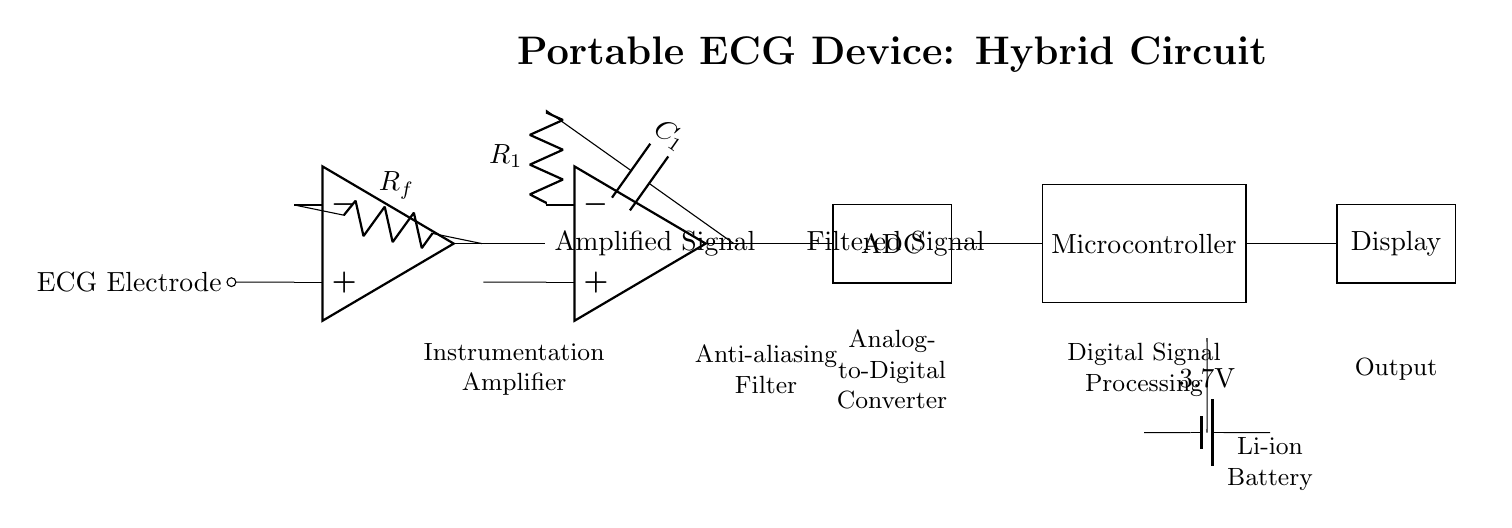What is the main purpose of the instrumentation amplifier in this circuit? The instrumentation amplifier amplifies the small ECG signal from the electrodes for better processing by subsequent stages. Its role is essential for ensuring that the signal is detectable above noise levels.
Answer: Amplification What components constitute the low-pass filter in this circuit? The low-pass filter consists of a resistor and a capacitor. In the diagram, they are labeled as R1 and C1, working together to reduce high-frequency noise while allowing lower frequencies of the ECG signal to pass through.
Answer: R1 and C1 What type of signal does the ADC convert in this circuit? The ADC converts the analog signal, which is filtered and amplified from the ECG signal into a digital form that can be processed by the microcontroller. This step is crucial for digital applications.
Answer: Analog to Digital What is the output device connected to the microcontroller? The output device in this hybrid circuit is a display, which presents the processed ECG data to the user in a visual format, making it easier to interpret the results.
Answer: Display Explain why a battery is used in this ECG circuit. A battery provides portable power to the ECG device, enabling it to function independently without being plugged into an electrical outlet. This feature is essential for medical devices used in remote locations or mobile applications.
Answer: Portable Power 